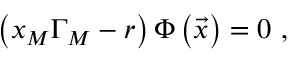<formula> <loc_0><loc_0><loc_500><loc_500>\left ( x _ { M } \Gamma _ { M } - r \right ) \Phi \left ( \vec { x } \right ) = 0 \ ,</formula> 